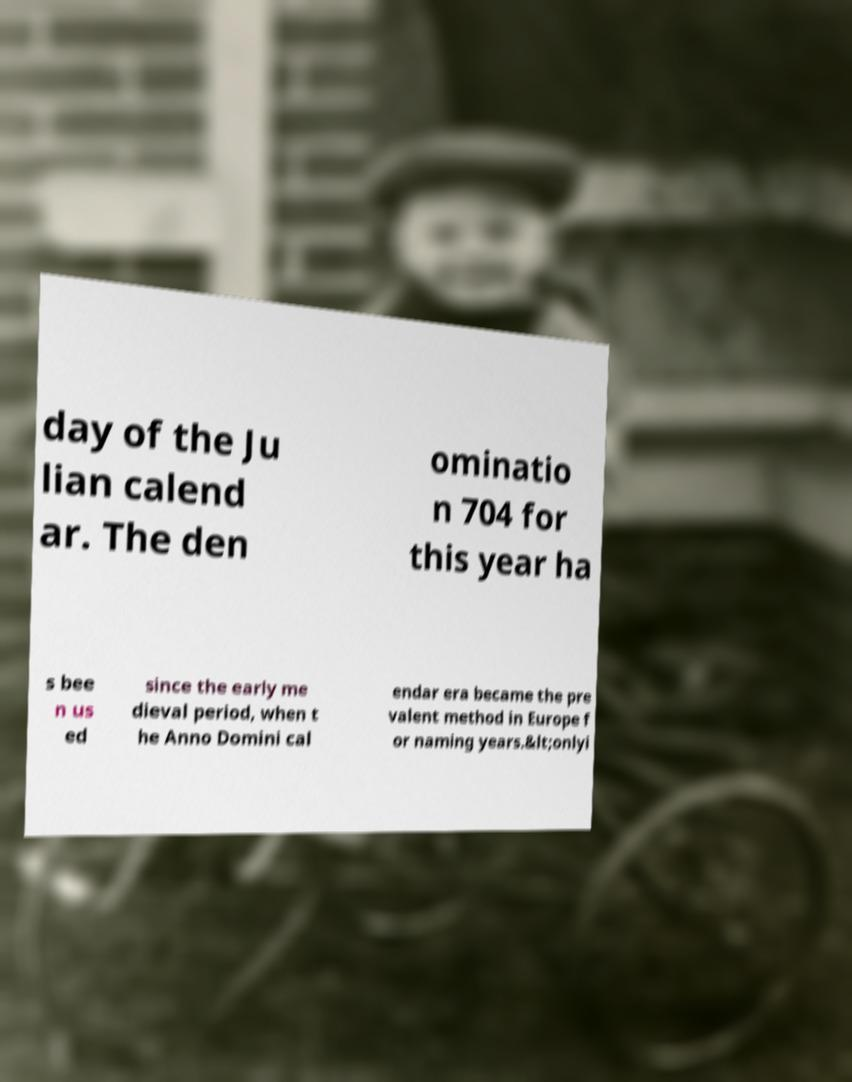Please read and relay the text visible in this image. What does it say? day of the Ju lian calend ar. The den ominatio n 704 for this year ha s bee n us ed since the early me dieval period, when t he Anno Domini cal endar era became the pre valent method in Europe f or naming years.&lt;onlyi 